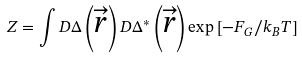<formula> <loc_0><loc_0><loc_500><loc_500>Z = \int D \Delta \left ( \overrightarrow { r } \right ) D \Delta ^ { \ast } \left ( \overrightarrow { r } \right ) \exp \left [ - F _ { G } / k _ { B } T \right ]</formula> 